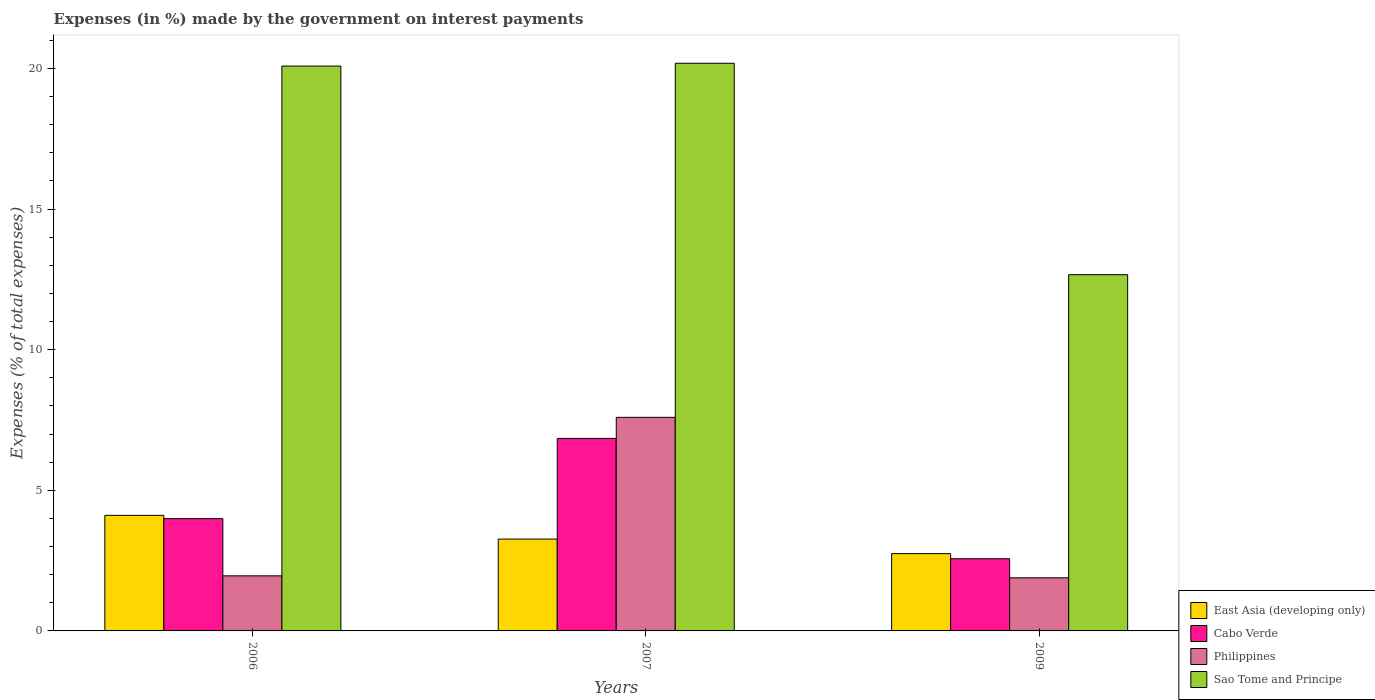How many groups of bars are there?
Offer a terse response. 3. In how many cases, is the number of bars for a given year not equal to the number of legend labels?
Offer a terse response. 0. What is the percentage of expenses made by the government on interest payments in Philippines in 2006?
Make the answer very short. 1.96. Across all years, what is the maximum percentage of expenses made by the government on interest payments in Philippines?
Your answer should be very brief. 7.59. Across all years, what is the minimum percentage of expenses made by the government on interest payments in Cabo Verde?
Ensure brevity in your answer.  2.57. In which year was the percentage of expenses made by the government on interest payments in Cabo Verde maximum?
Offer a terse response. 2007. In which year was the percentage of expenses made by the government on interest payments in Cabo Verde minimum?
Offer a terse response. 2009. What is the total percentage of expenses made by the government on interest payments in East Asia (developing only) in the graph?
Your answer should be compact. 10.12. What is the difference between the percentage of expenses made by the government on interest payments in Cabo Verde in 2007 and that in 2009?
Offer a very short reply. 4.28. What is the difference between the percentage of expenses made by the government on interest payments in Sao Tome and Principe in 2009 and the percentage of expenses made by the government on interest payments in East Asia (developing only) in 2006?
Provide a succinct answer. 8.56. What is the average percentage of expenses made by the government on interest payments in East Asia (developing only) per year?
Offer a very short reply. 3.37. In the year 2006, what is the difference between the percentage of expenses made by the government on interest payments in Sao Tome and Principe and percentage of expenses made by the government on interest payments in Cabo Verde?
Your answer should be very brief. 16.09. In how many years, is the percentage of expenses made by the government on interest payments in Cabo Verde greater than 3 %?
Make the answer very short. 2. What is the ratio of the percentage of expenses made by the government on interest payments in Philippines in 2007 to that in 2009?
Provide a succinct answer. 4.02. What is the difference between the highest and the second highest percentage of expenses made by the government on interest payments in Sao Tome and Principe?
Keep it short and to the point. 0.1. What is the difference between the highest and the lowest percentage of expenses made by the government on interest payments in Cabo Verde?
Keep it short and to the point. 4.28. What does the 2nd bar from the left in 2006 represents?
Make the answer very short. Cabo Verde. What does the 3rd bar from the right in 2007 represents?
Keep it short and to the point. Cabo Verde. Is it the case that in every year, the sum of the percentage of expenses made by the government on interest payments in Cabo Verde and percentage of expenses made by the government on interest payments in Philippines is greater than the percentage of expenses made by the government on interest payments in Sao Tome and Principe?
Keep it short and to the point. No. Are all the bars in the graph horizontal?
Provide a succinct answer. No. How many years are there in the graph?
Provide a succinct answer. 3. What is the difference between two consecutive major ticks on the Y-axis?
Ensure brevity in your answer.  5. Are the values on the major ticks of Y-axis written in scientific E-notation?
Your answer should be very brief. No. Does the graph contain any zero values?
Keep it short and to the point. No. Where does the legend appear in the graph?
Your answer should be compact. Bottom right. What is the title of the graph?
Offer a terse response. Expenses (in %) made by the government on interest payments. Does "Palau" appear as one of the legend labels in the graph?
Give a very brief answer. No. What is the label or title of the X-axis?
Make the answer very short. Years. What is the label or title of the Y-axis?
Ensure brevity in your answer.  Expenses (% of total expenses). What is the Expenses (% of total expenses) in East Asia (developing only) in 2006?
Offer a very short reply. 4.11. What is the Expenses (% of total expenses) in Cabo Verde in 2006?
Keep it short and to the point. 3.99. What is the Expenses (% of total expenses) in Philippines in 2006?
Make the answer very short. 1.96. What is the Expenses (% of total expenses) of Sao Tome and Principe in 2006?
Your answer should be compact. 20.09. What is the Expenses (% of total expenses) in East Asia (developing only) in 2007?
Provide a succinct answer. 3.27. What is the Expenses (% of total expenses) in Cabo Verde in 2007?
Make the answer very short. 6.84. What is the Expenses (% of total expenses) of Philippines in 2007?
Your answer should be very brief. 7.59. What is the Expenses (% of total expenses) of Sao Tome and Principe in 2007?
Your answer should be very brief. 20.19. What is the Expenses (% of total expenses) of East Asia (developing only) in 2009?
Your answer should be compact. 2.75. What is the Expenses (% of total expenses) of Cabo Verde in 2009?
Make the answer very short. 2.57. What is the Expenses (% of total expenses) in Philippines in 2009?
Offer a terse response. 1.89. What is the Expenses (% of total expenses) in Sao Tome and Principe in 2009?
Keep it short and to the point. 12.67. Across all years, what is the maximum Expenses (% of total expenses) of East Asia (developing only)?
Ensure brevity in your answer.  4.11. Across all years, what is the maximum Expenses (% of total expenses) of Cabo Verde?
Offer a terse response. 6.84. Across all years, what is the maximum Expenses (% of total expenses) of Philippines?
Your response must be concise. 7.59. Across all years, what is the maximum Expenses (% of total expenses) of Sao Tome and Principe?
Make the answer very short. 20.19. Across all years, what is the minimum Expenses (% of total expenses) in East Asia (developing only)?
Make the answer very short. 2.75. Across all years, what is the minimum Expenses (% of total expenses) in Cabo Verde?
Offer a very short reply. 2.57. Across all years, what is the minimum Expenses (% of total expenses) of Philippines?
Make the answer very short. 1.89. Across all years, what is the minimum Expenses (% of total expenses) of Sao Tome and Principe?
Keep it short and to the point. 12.67. What is the total Expenses (% of total expenses) in East Asia (developing only) in the graph?
Ensure brevity in your answer.  10.12. What is the total Expenses (% of total expenses) of Cabo Verde in the graph?
Offer a terse response. 13.4. What is the total Expenses (% of total expenses) of Philippines in the graph?
Keep it short and to the point. 11.44. What is the total Expenses (% of total expenses) of Sao Tome and Principe in the graph?
Your response must be concise. 52.94. What is the difference between the Expenses (% of total expenses) in East Asia (developing only) in 2006 and that in 2007?
Make the answer very short. 0.84. What is the difference between the Expenses (% of total expenses) of Cabo Verde in 2006 and that in 2007?
Provide a short and direct response. -2.85. What is the difference between the Expenses (% of total expenses) in Philippines in 2006 and that in 2007?
Your response must be concise. -5.64. What is the difference between the Expenses (% of total expenses) in Sao Tome and Principe in 2006 and that in 2007?
Your answer should be very brief. -0.1. What is the difference between the Expenses (% of total expenses) of East Asia (developing only) in 2006 and that in 2009?
Offer a terse response. 1.36. What is the difference between the Expenses (% of total expenses) in Cabo Verde in 2006 and that in 2009?
Make the answer very short. 1.43. What is the difference between the Expenses (% of total expenses) of Philippines in 2006 and that in 2009?
Ensure brevity in your answer.  0.07. What is the difference between the Expenses (% of total expenses) of Sao Tome and Principe in 2006 and that in 2009?
Your answer should be compact. 7.42. What is the difference between the Expenses (% of total expenses) in East Asia (developing only) in 2007 and that in 2009?
Offer a very short reply. 0.52. What is the difference between the Expenses (% of total expenses) in Cabo Verde in 2007 and that in 2009?
Offer a very short reply. 4.28. What is the difference between the Expenses (% of total expenses) in Philippines in 2007 and that in 2009?
Your answer should be compact. 5.71. What is the difference between the Expenses (% of total expenses) of Sao Tome and Principe in 2007 and that in 2009?
Provide a succinct answer. 7.52. What is the difference between the Expenses (% of total expenses) in East Asia (developing only) in 2006 and the Expenses (% of total expenses) in Cabo Verde in 2007?
Offer a very short reply. -2.74. What is the difference between the Expenses (% of total expenses) in East Asia (developing only) in 2006 and the Expenses (% of total expenses) in Philippines in 2007?
Provide a short and direct response. -3.48. What is the difference between the Expenses (% of total expenses) of East Asia (developing only) in 2006 and the Expenses (% of total expenses) of Sao Tome and Principe in 2007?
Ensure brevity in your answer.  -16.08. What is the difference between the Expenses (% of total expenses) of Cabo Verde in 2006 and the Expenses (% of total expenses) of Philippines in 2007?
Provide a short and direct response. -3.6. What is the difference between the Expenses (% of total expenses) in Cabo Verde in 2006 and the Expenses (% of total expenses) in Sao Tome and Principe in 2007?
Your response must be concise. -16.19. What is the difference between the Expenses (% of total expenses) of Philippines in 2006 and the Expenses (% of total expenses) of Sao Tome and Principe in 2007?
Provide a short and direct response. -18.23. What is the difference between the Expenses (% of total expenses) in East Asia (developing only) in 2006 and the Expenses (% of total expenses) in Cabo Verde in 2009?
Your response must be concise. 1.54. What is the difference between the Expenses (% of total expenses) in East Asia (developing only) in 2006 and the Expenses (% of total expenses) in Philippines in 2009?
Provide a succinct answer. 2.22. What is the difference between the Expenses (% of total expenses) in East Asia (developing only) in 2006 and the Expenses (% of total expenses) in Sao Tome and Principe in 2009?
Offer a terse response. -8.56. What is the difference between the Expenses (% of total expenses) in Cabo Verde in 2006 and the Expenses (% of total expenses) in Philippines in 2009?
Ensure brevity in your answer.  2.1. What is the difference between the Expenses (% of total expenses) of Cabo Verde in 2006 and the Expenses (% of total expenses) of Sao Tome and Principe in 2009?
Your answer should be very brief. -8.67. What is the difference between the Expenses (% of total expenses) in Philippines in 2006 and the Expenses (% of total expenses) in Sao Tome and Principe in 2009?
Ensure brevity in your answer.  -10.71. What is the difference between the Expenses (% of total expenses) in East Asia (developing only) in 2007 and the Expenses (% of total expenses) in Cabo Verde in 2009?
Offer a very short reply. 0.7. What is the difference between the Expenses (% of total expenses) of East Asia (developing only) in 2007 and the Expenses (% of total expenses) of Philippines in 2009?
Your response must be concise. 1.38. What is the difference between the Expenses (% of total expenses) of East Asia (developing only) in 2007 and the Expenses (% of total expenses) of Sao Tome and Principe in 2009?
Provide a short and direct response. -9.4. What is the difference between the Expenses (% of total expenses) in Cabo Verde in 2007 and the Expenses (% of total expenses) in Philippines in 2009?
Provide a succinct answer. 4.96. What is the difference between the Expenses (% of total expenses) of Cabo Verde in 2007 and the Expenses (% of total expenses) of Sao Tome and Principe in 2009?
Make the answer very short. -5.82. What is the difference between the Expenses (% of total expenses) in Philippines in 2007 and the Expenses (% of total expenses) in Sao Tome and Principe in 2009?
Provide a succinct answer. -5.07. What is the average Expenses (% of total expenses) of East Asia (developing only) per year?
Provide a short and direct response. 3.37. What is the average Expenses (% of total expenses) of Cabo Verde per year?
Offer a terse response. 4.47. What is the average Expenses (% of total expenses) of Philippines per year?
Your response must be concise. 3.81. What is the average Expenses (% of total expenses) in Sao Tome and Principe per year?
Make the answer very short. 17.65. In the year 2006, what is the difference between the Expenses (% of total expenses) of East Asia (developing only) and Expenses (% of total expenses) of Cabo Verde?
Provide a short and direct response. 0.12. In the year 2006, what is the difference between the Expenses (% of total expenses) in East Asia (developing only) and Expenses (% of total expenses) in Philippines?
Provide a succinct answer. 2.15. In the year 2006, what is the difference between the Expenses (% of total expenses) of East Asia (developing only) and Expenses (% of total expenses) of Sao Tome and Principe?
Your answer should be very brief. -15.98. In the year 2006, what is the difference between the Expenses (% of total expenses) in Cabo Verde and Expenses (% of total expenses) in Philippines?
Offer a terse response. 2.03. In the year 2006, what is the difference between the Expenses (% of total expenses) of Cabo Verde and Expenses (% of total expenses) of Sao Tome and Principe?
Give a very brief answer. -16.09. In the year 2006, what is the difference between the Expenses (% of total expenses) of Philippines and Expenses (% of total expenses) of Sao Tome and Principe?
Provide a short and direct response. -18.13. In the year 2007, what is the difference between the Expenses (% of total expenses) of East Asia (developing only) and Expenses (% of total expenses) of Cabo Verde?
Provide a succinct answer. -3.58. In the year 2007, what is the difference between the Expenses (% of total expenses) of East Asia (developing only) and Expenses (% of total expenses) of Philippines?
Make the answer very short. -4.33. In the year 2007, what is the difference between the Expenses (% of total expenses) of East Asia (developing only) and Expenses (% of total expenses) of Sao Tome and Principe?
Keep it short and to the point. -16.92. In the year 2007, what is the difference between the Expenses (% of total expenses) of Cabo Verde and Expenses (% of total expenses) of Philippines?
Your answer should be very brief. -0.75. In the year 2007, what is the difference between the Expenses (% of total expenses) in Cabo Verde and Expenses (% of total expenses) in Sao Tome and Principe?
Ensure brevity in your answer.  -13.34. In the year 2007, what is the difference between the Expenses (% of total expenses) in Philippines and Expenses (% of total expenses) in Sao Tome and Principe?
Offer a terse response. -12.59. In the year 2009, what is the difference between the Expenses (% of total expenses) in East Asia (developing only) and Expenses (% of total expenses) in Cabo Verde?
Keep it short and to the point. 0.18. In the year 2009, what is the difference between the Expenses (% of total expenses) in East Asia (developing only) and Expenses (% of total expenses) in Philippines?
Your answer should be very brief. 0.86. In the year 2009, what is the difference between the Expenses (% of total expenses) of East Asia (developing only) and Expenses (% of total expenses) of Sao Tome and Principe?
Make the answer very short. -9.92. In the year 2009, what is the difference between the Expenses (% of total expenses) of Cabo Verde and Expenses (% of total expenses) of Philippines?
Your answer should be compact. 0.68. In the year 2009, what is the difference between the Expenses (% of total expenses) of Cabo Verde and Expenses (% of total expenses) of Sao Tome and Principe?
Ensure brevity in your answer.  -10.1. In the year 2009, what is the difference between the Expenses (% of total expenses) in Philippines and Expenses (% of total expenses) in Sao Tome and Principe?
Give a very brief answer. -10.78. What is the ratio of the Expenses (% of total expenses) of East Asia (developing only) in 2006 to that in 2007?
Offer a terse response. 1.26. What is the ratio of the Expenses (% of total expenses) of Cabo Verde in 2006 to that in 2007?
Offer a very short reply. 0.58. What is the ratio of the Expenses (% of total expenses) in Philippines in 2006 to that in 2007?
Provide a short and direct response. 0.26. What is the ratio of the Expenses (% of total expenses) of East Asia (developing only) in 2006 to that in 2009?
Give a very brief answer. 1.5. What is the ratio of the Expenses (% of total expenses) in Cabo Verde in 2006 to that in 2009?
Provide a short and direct response. 1.56. What is the ratio of the Expenses (% of total expenses) in Sao Tome and Principe in 2006 to that in 2009?
Your answer should be very brief. 1.59. What is the ratio of the Expenses (% of total expenses) in East Asia (developing only) in 2007 to that in 2009?
Keep it short and to the point. 1.19. What is the ratio of the Expenses (% of total expenses) of Cabo Verde in 2007 to that in 2009?
Provide a short and direct response. 2.67. What is the ratio of the Expenses (% of total expenses) in Philippines in 2007 to that in 2009?
Provide a succinct answer. 4.02. What is the ratio of the Expenses (% of total expenses) of Sao Tome and Principe in 2007 to that in 2009?
Keep it short and to the point. 1.59. What is the difference between the highest and the second highest Expenses (% of total expenses) of East Asia (developing only)?
Make the answer very short. 0.84. What is the difference between the highest and the second highest Expenses (% of total expenses) of Cabo Verde?
Ensure brevity in your answer.  2.85. What is the difference between the highest and the second highest Expenses (% of total expenses) of Philippines?
Provide a succinct answer. 5.64. What is the difference between the highest and the second highest Expenses (% of total expenses) in Sao Tome and Principe?
Offer a very short reply. 0.1. What is the difference between the highest and the lowest Expenses (% of total expenses) of East Asia (developing only)?
Keep it short and to the point. 1.36. What is the difference between the highest and the lowest Expenses (% of total expenses) in Cabo Verde?
Offer a terse response. 4.28. What is the difference between the highest and the lowest Expenses (% of total expenses) of Philippines?
Provide a succinct answer. 5.71. What is the difference between the highest and the lowest Expenses (% of total expenses) in Sao Tome and Principe?
Offer a very short reply. 7.52. 